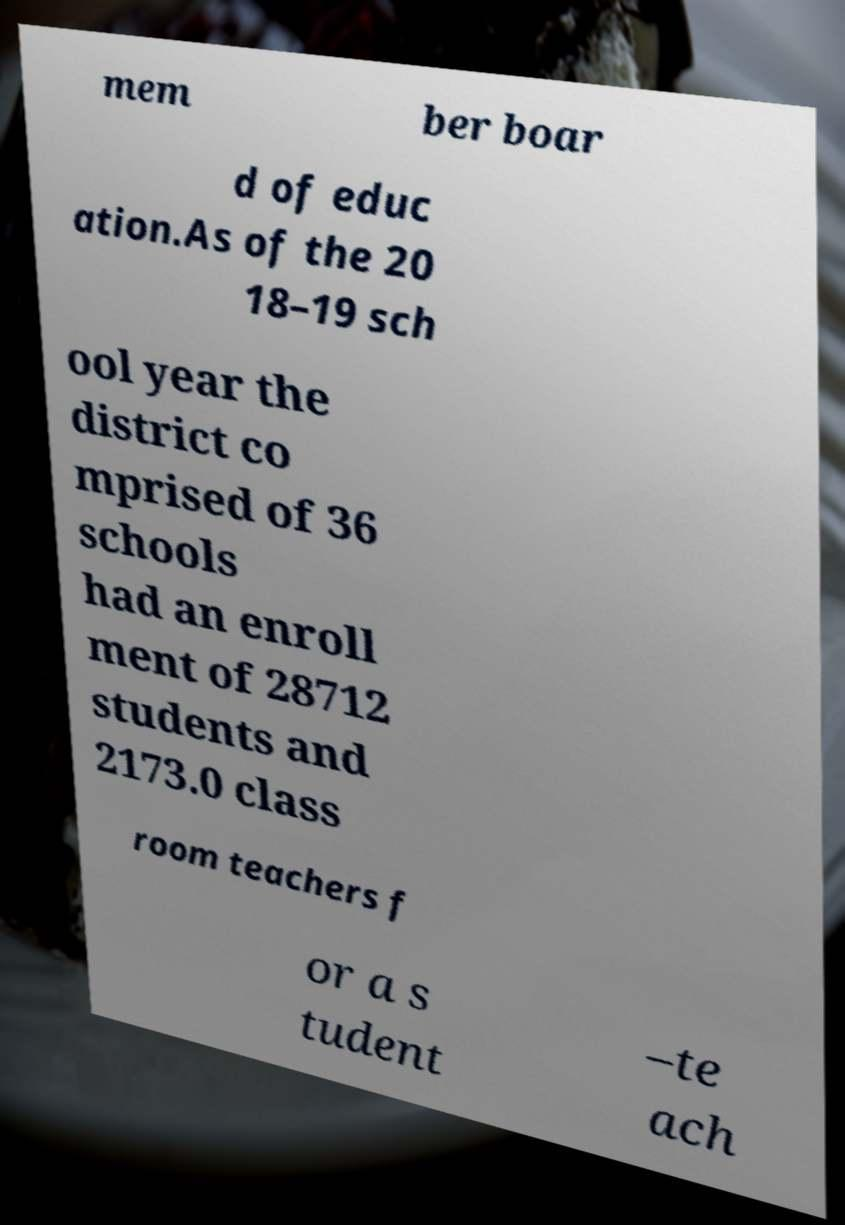Please read and relay the text visible in this image. What does it say? mem ber boar d of educ ation.As of the 20 18–19 sch ool year the district co mprised of 36 schools had an enroll ment of 28712 students and 2173.0 class room teachers f or a s tudent –te ach 